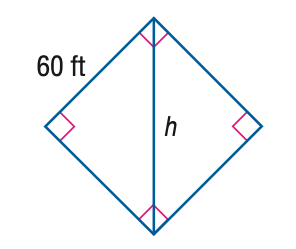Answer the mathemtical geometry problem and directly provide the correct option letter.
Question: Find the value of h.
Choices: A: 60 B: 84.85 C: 103.92 D: 120 B 